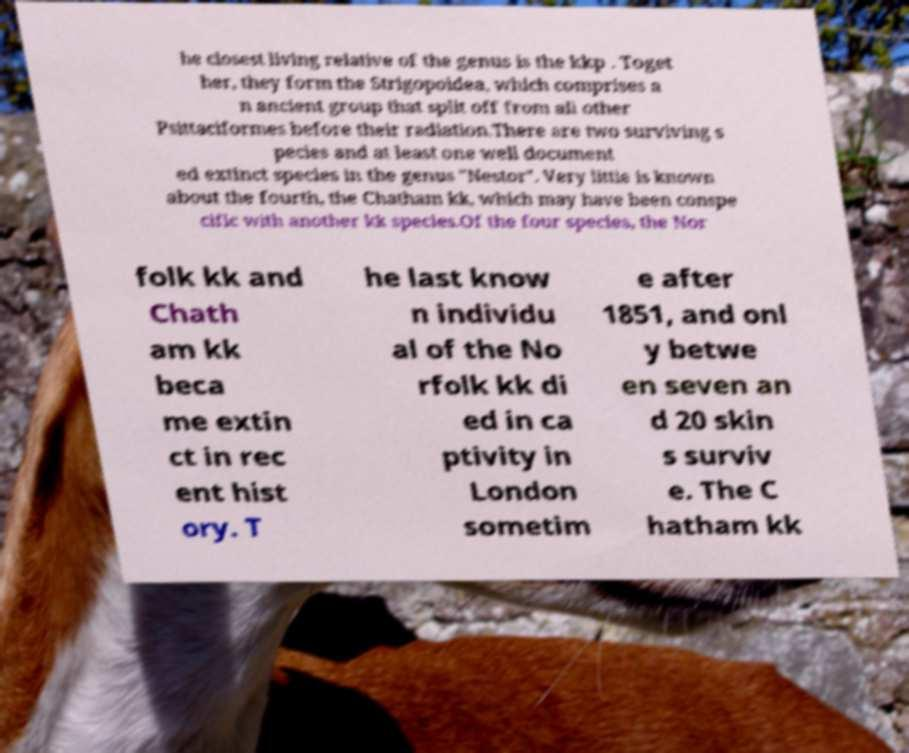Can you accurately transcribe the text from the provided image for me? he closest living relative of the genus is the kkp . Toget her, they form the Strigopoidea, which comprises a n ancient group that split off from all other Psittaciformes before their radiation.There are two surviving s pecies and at least one well document ed extinct species in the genus "Nestor". Very little is known about the fourth, the Chatham kk, which may have been conspe cific with another kk species.Of the four species, the Nor folk kk and Chath am kk beca me extin ct in rec ent hist ory. T he last know n individu al of the No rfolk kk di ed in ca ptivity in London sometim e after 1851, and onl y betwe en seven an d 20 skin s surviv e. The C hatham kk 